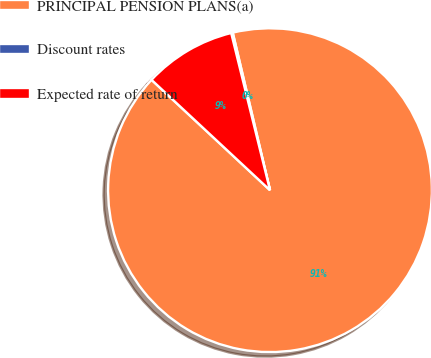Convert chart to OTSL. <chart><loc_0><loc_0><loc_500><loc_500><pie_chart><fcel>PRINCIPAL PENSION PLANS(a)<fcel>Discount rates<fcel>Expected rate of return<nl><fcel>90.63%<fcel>0.16%<fcel>9.21%<nl></chart> 